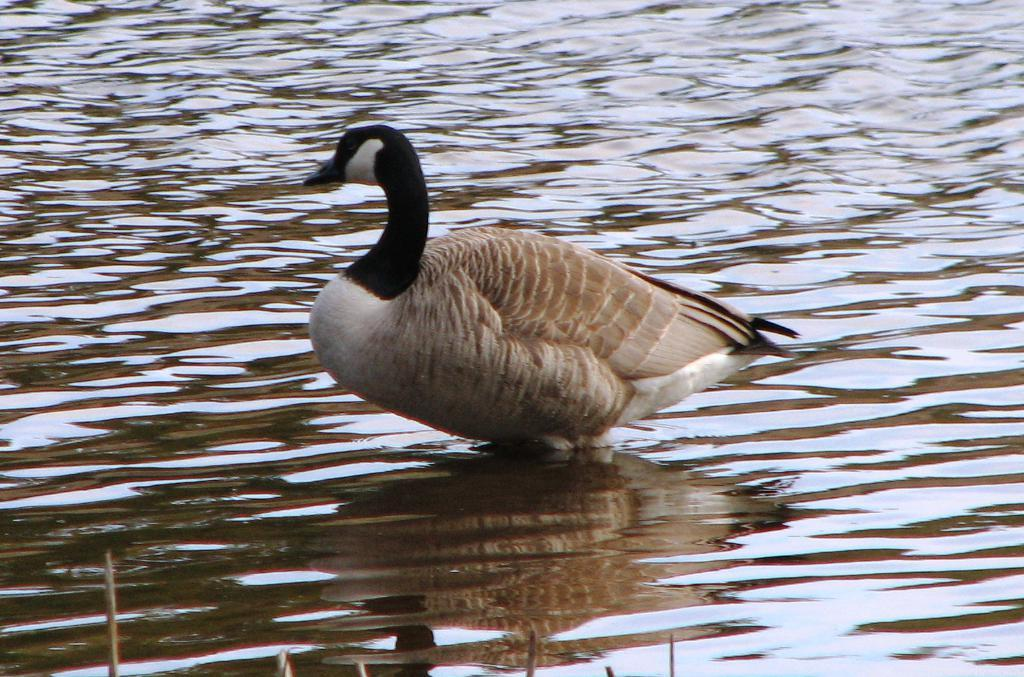What type of animal can be seen in the water in the image? There is a white and black duck in the water in the image. What else can be seen at the bottom of the image? There are sticks visible at the bottom of the image. What type of notebook is being used during the discussion in the image? There is no notebook or discussion present in the image; it features a white and black duck in the water and sticks at the bottom. 